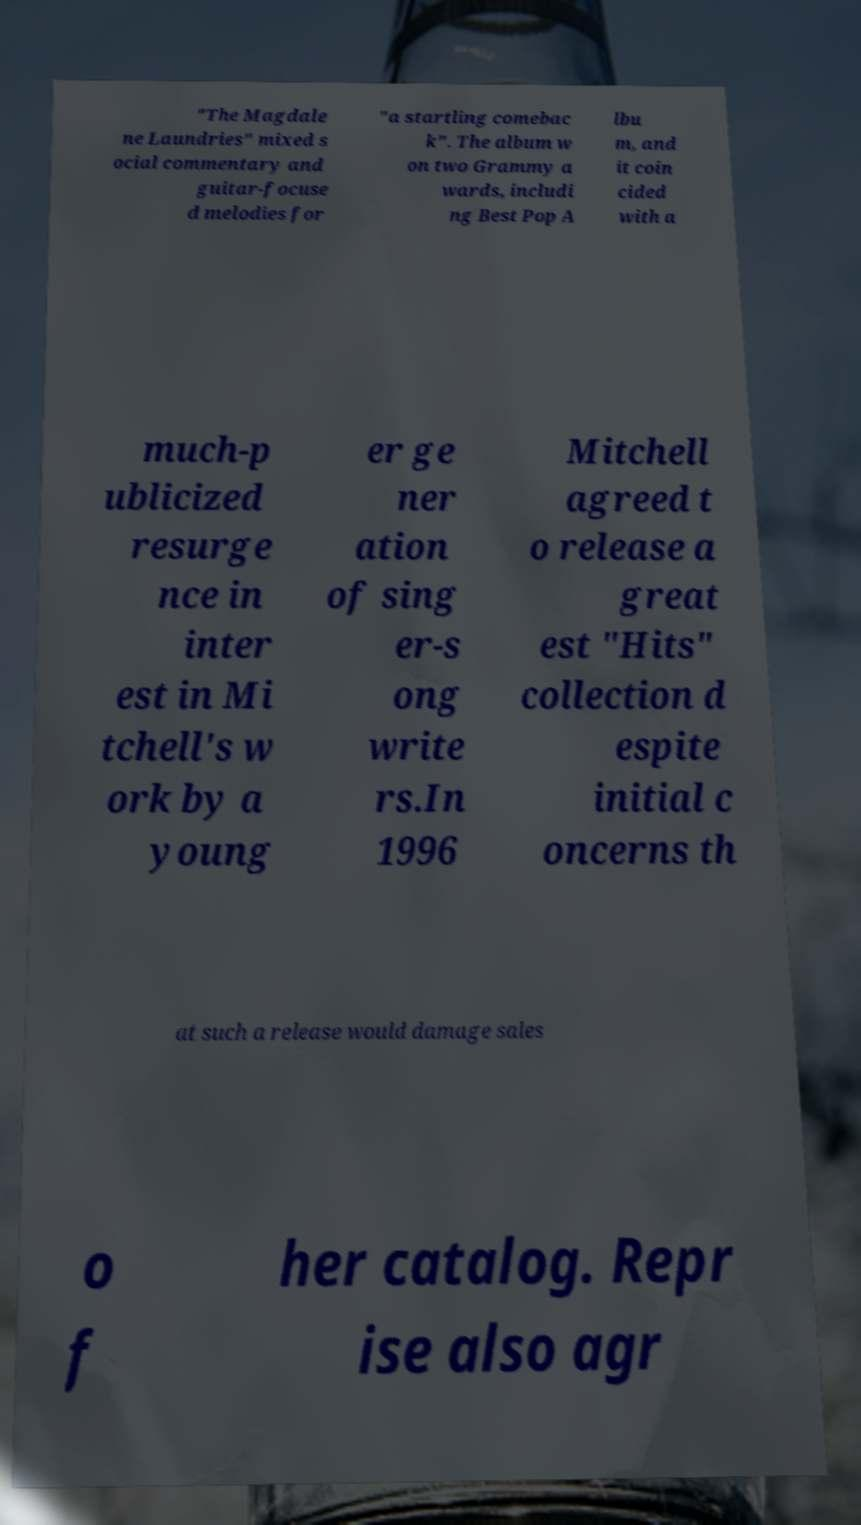Can you read and provide the text displayed in the image?This photo seems to have some interesting text. Can you extract and type it out for me? "The Magdale ne Laundries" mixed s ocial commentary and guitar-focuse d melodies for "a startling comebac k". The album w on two Grammy a wards, includi ng Best Pop A lbu m, and it coin cided with a much-p ublicized resurge nce in inter est in Mi tchell's w ork by a young er ge ner ation of sing er-s ong write rs.In 1996 Mitchell agreed t o release a great est "Hits" collection d espite initial c oncerns th at such a release would damage sales o f her catalog. Repr ise also agr 